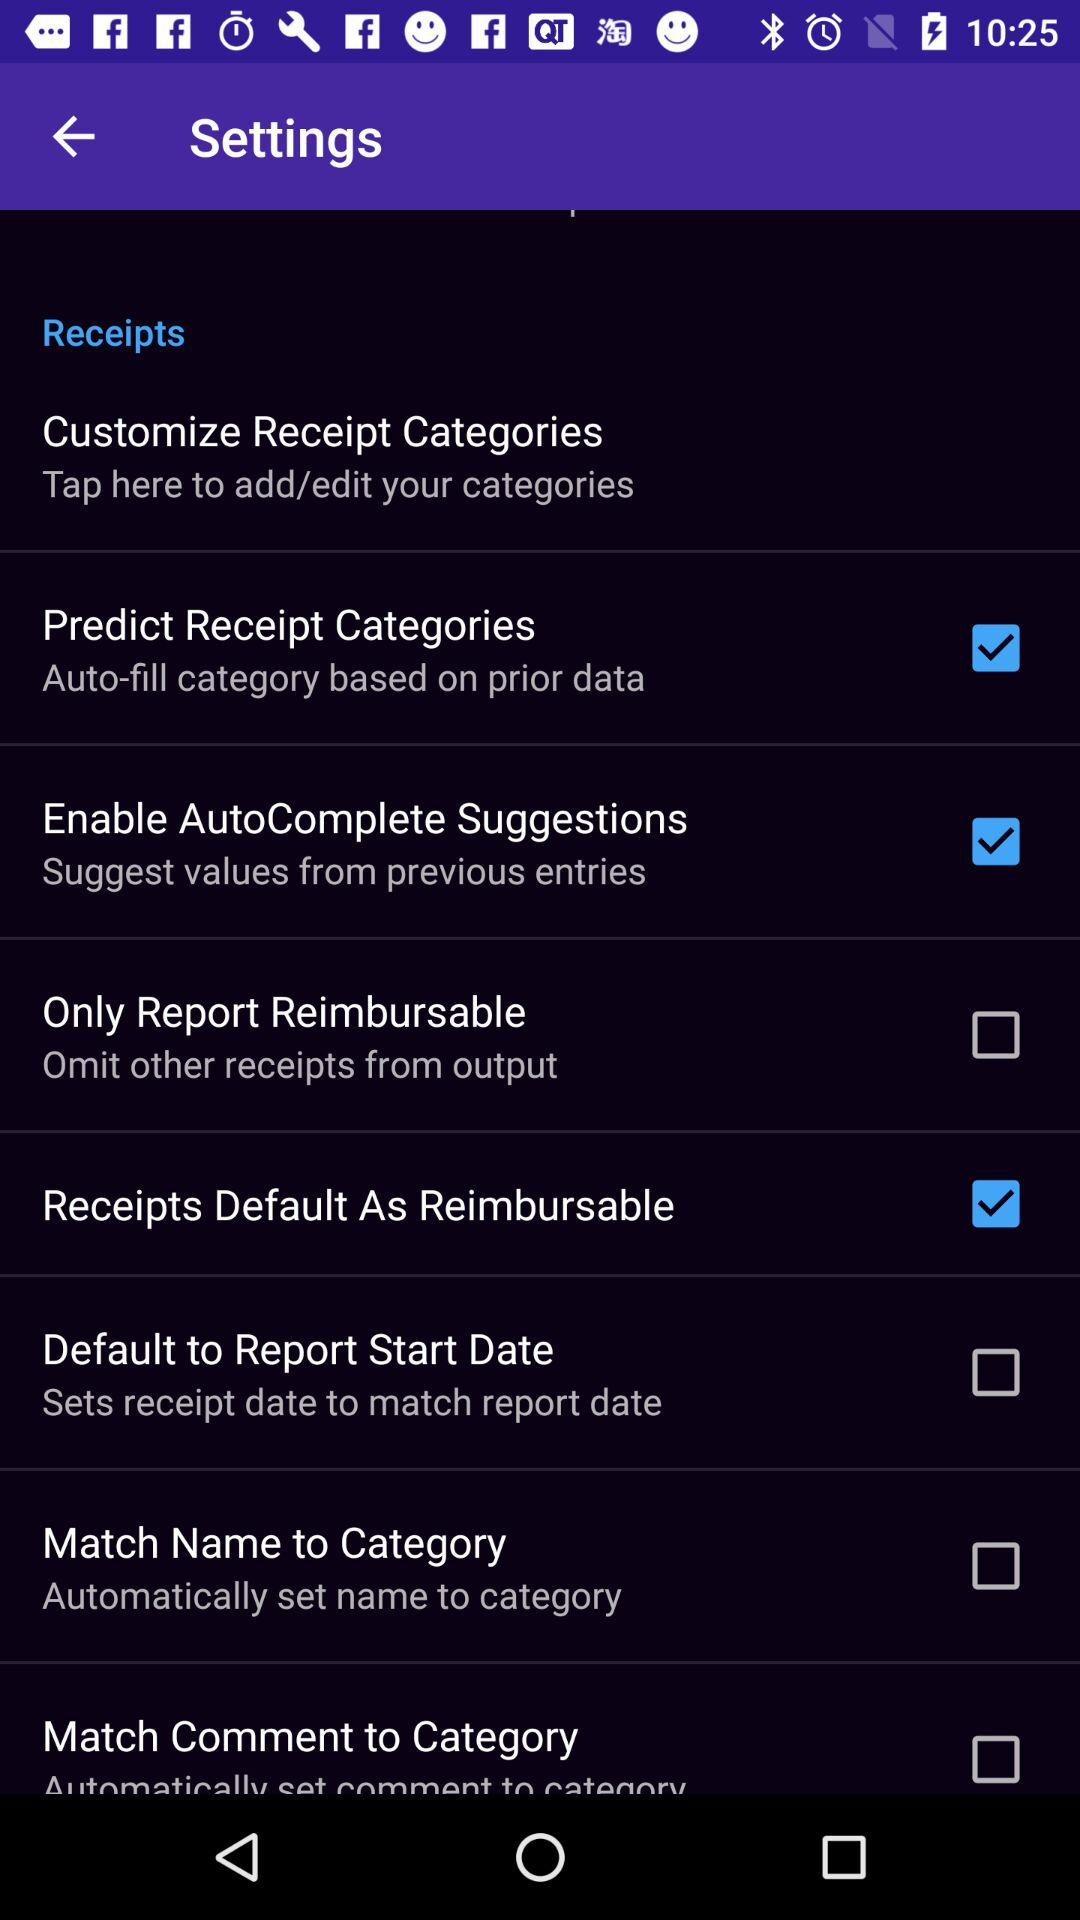What is the current status of Only Report Reimbursable? The status is "off". 